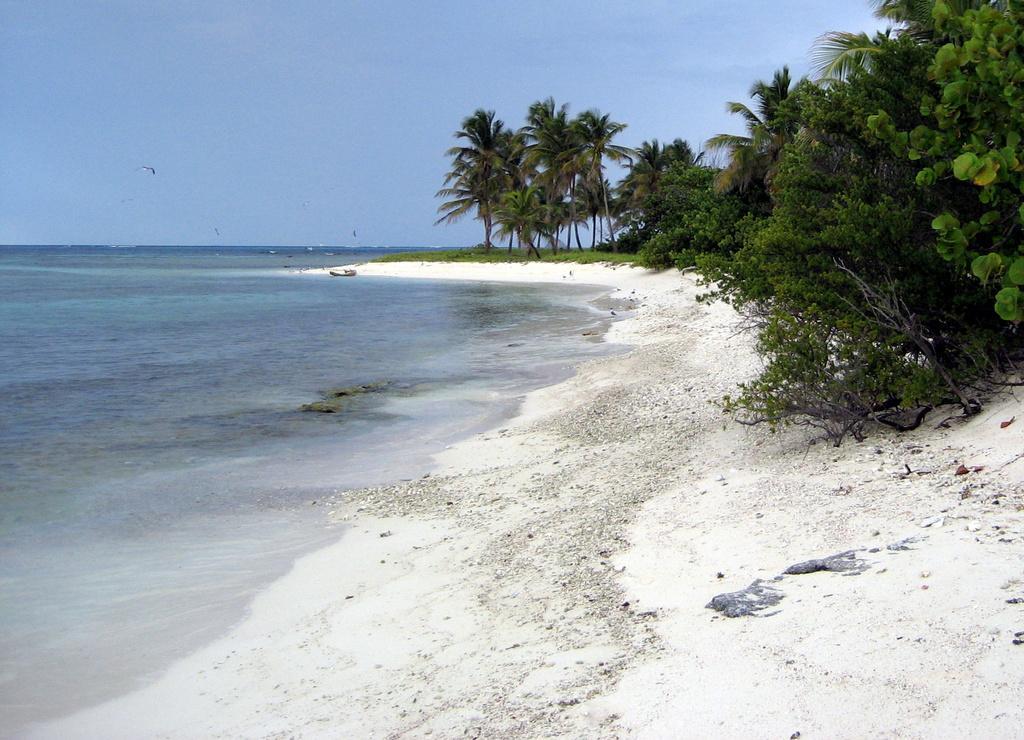In one or two sentences, can you explain what this image depicts? At the bottom, we see the sand and the stones. On the right side, we see the trees. On the left side, we see water and this water might be in the sea. In the middle, we see a boat. There are trees in the background. At the top, we see the sky. This picture might be clicked at the seashore. 